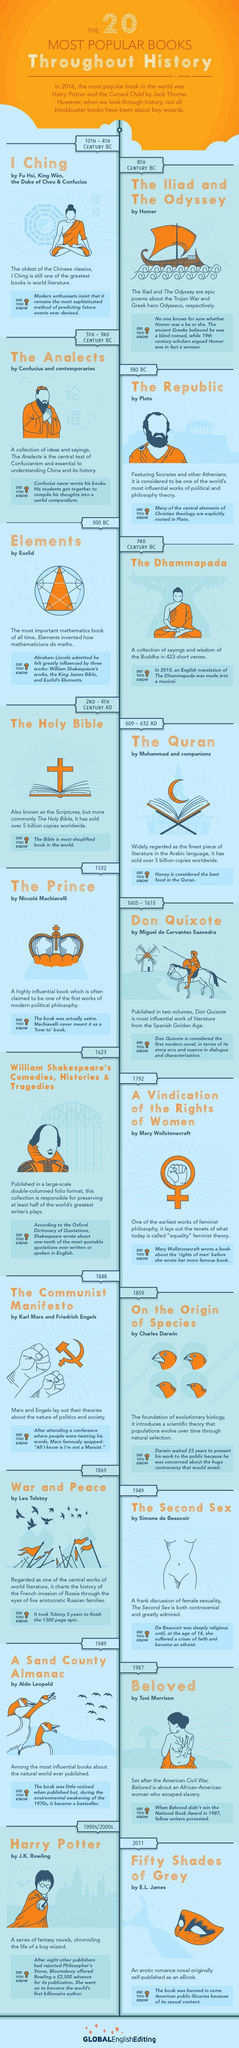Draw attention to some important aspects in this diagram. The Communist Manifesto was released in the year 1848. The Iliad and the Odyssey, two of the most famous books in history, were published in the 8th century BC. Aldo Leopold's work, titled 'A Sand County Almanac,' is a well-known publication. The book "On The Origin of Species" was written by Charles Darwin. During the 2nd to 4th centuries AD, the Holy Bible was written. 